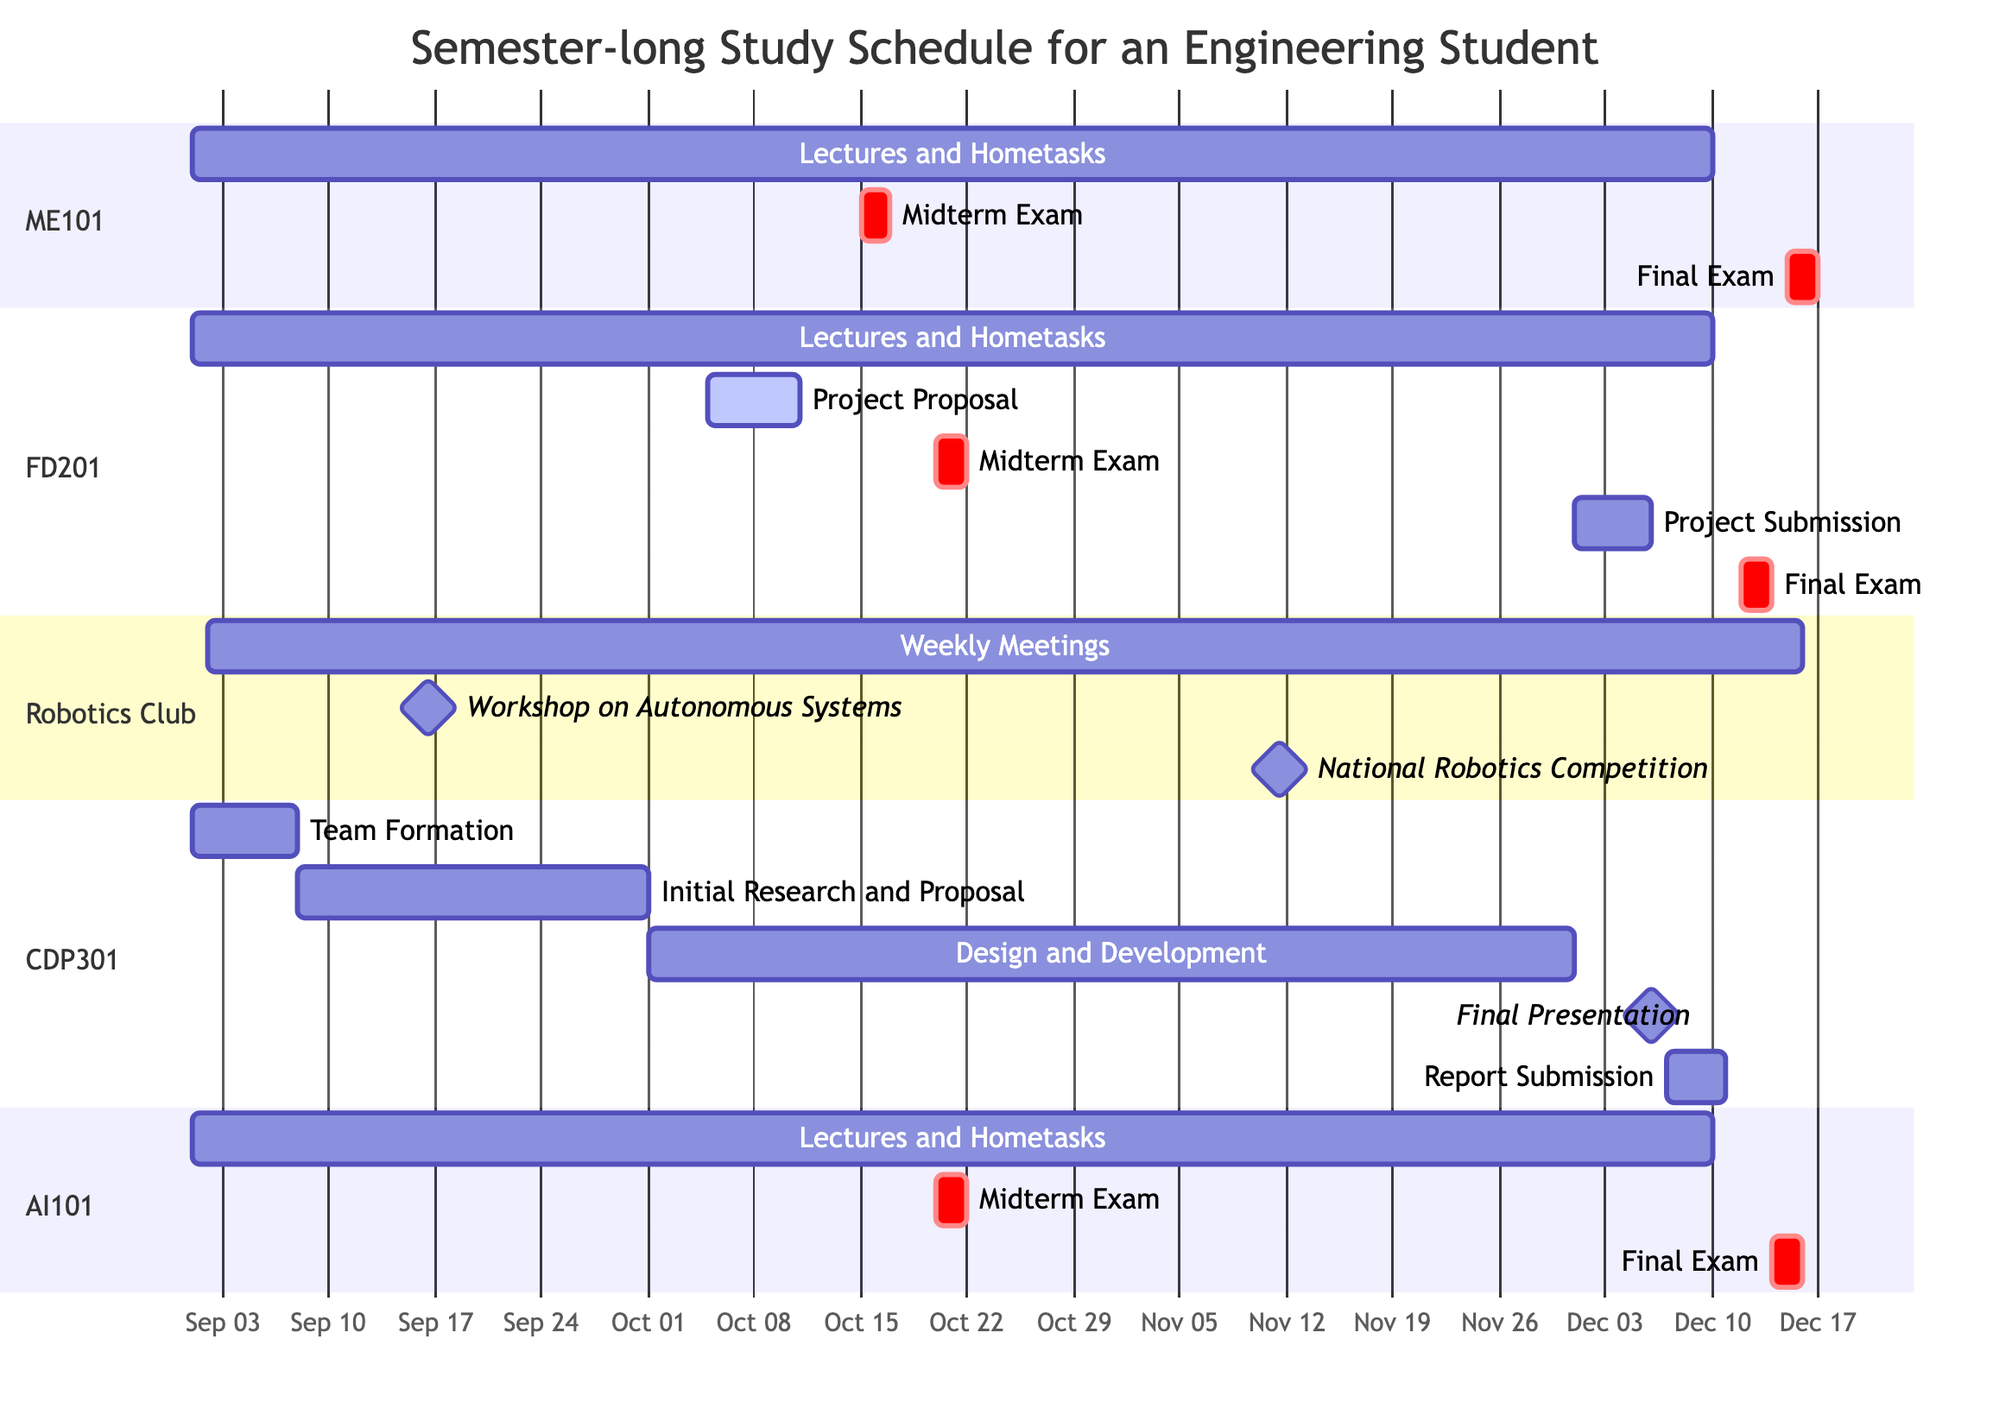What is the duration of the "Design and Development" task in the Capstone Design Project? The "Design and Development" task starts on October 1, 2023, and ends on November 30, 2023. To calculate the duration, we count the number of days between these two dates, which amounts to 61 days.
Answer: 61 days What are the dates for the Final Exam of the Fluid Dynamics course? The Final Exam for the Fluid Dynamics course is scheduled to start on December 12, 2023, and end on December 13, 2023. These dates can be directly read from the Gantt chart section for Fluid Dynamics.
Answer: December 12 - 13 How many total examinations are represented in this semester schedule? The semester schedule contains a total of five examinations: two Midterm Exams and three Final Exams for the various courses, which can be counted by looking at the examination tasks across all courses.
Answer: 5 What is the latest task deadline for all the courses listed? To find the latest task deadline, we check the end dates of all tasks. The Final Exam for Fluid Dynamics ends on December 13, 2023, while the Report Submission ends on December 10, 2023. Hence, December 13, 2023, is the latest.
Answer: December 13 Which course has overlapping tasks with the "Robotics Club Activities"? The tasks for the "Robotics Club Activities," particularly the "Weekly Meetings," overlap with various courses, especially with all of them since the meetings run from September 2, 2023, to December 16, 2023. Specifically, there is overlap with lectures for all courses that span the similar time frame.
Answer: All courses How many days apart are the Midterm Exams for Fluid Dynamics and Artificial Intelligence? Both Midterm Exams occur on October 20 and October 20, 2023, respectively. As they are on the same day, there are no days apart between them. Thus, the difference is zero days.
Answer: 0 days What is the main task type for the Robotics Club activities? The main task types for Robotics Club activities are "Weekly Meetings," "Workshop on Autonomous Systems," and "National Robotics Competition." However, the "Weekly Meetings" is the ongoing task type during the semester.
Answer: Weekly Meetings When does the "National Robotics Competition" take place? The "National Robotics Competition" is scheduled to commence on November 10, 2023, and conclude on November 12, 2023, which can be observed in the Robotics Club section of the Gantt chart.
Answer: November 10 - 12 